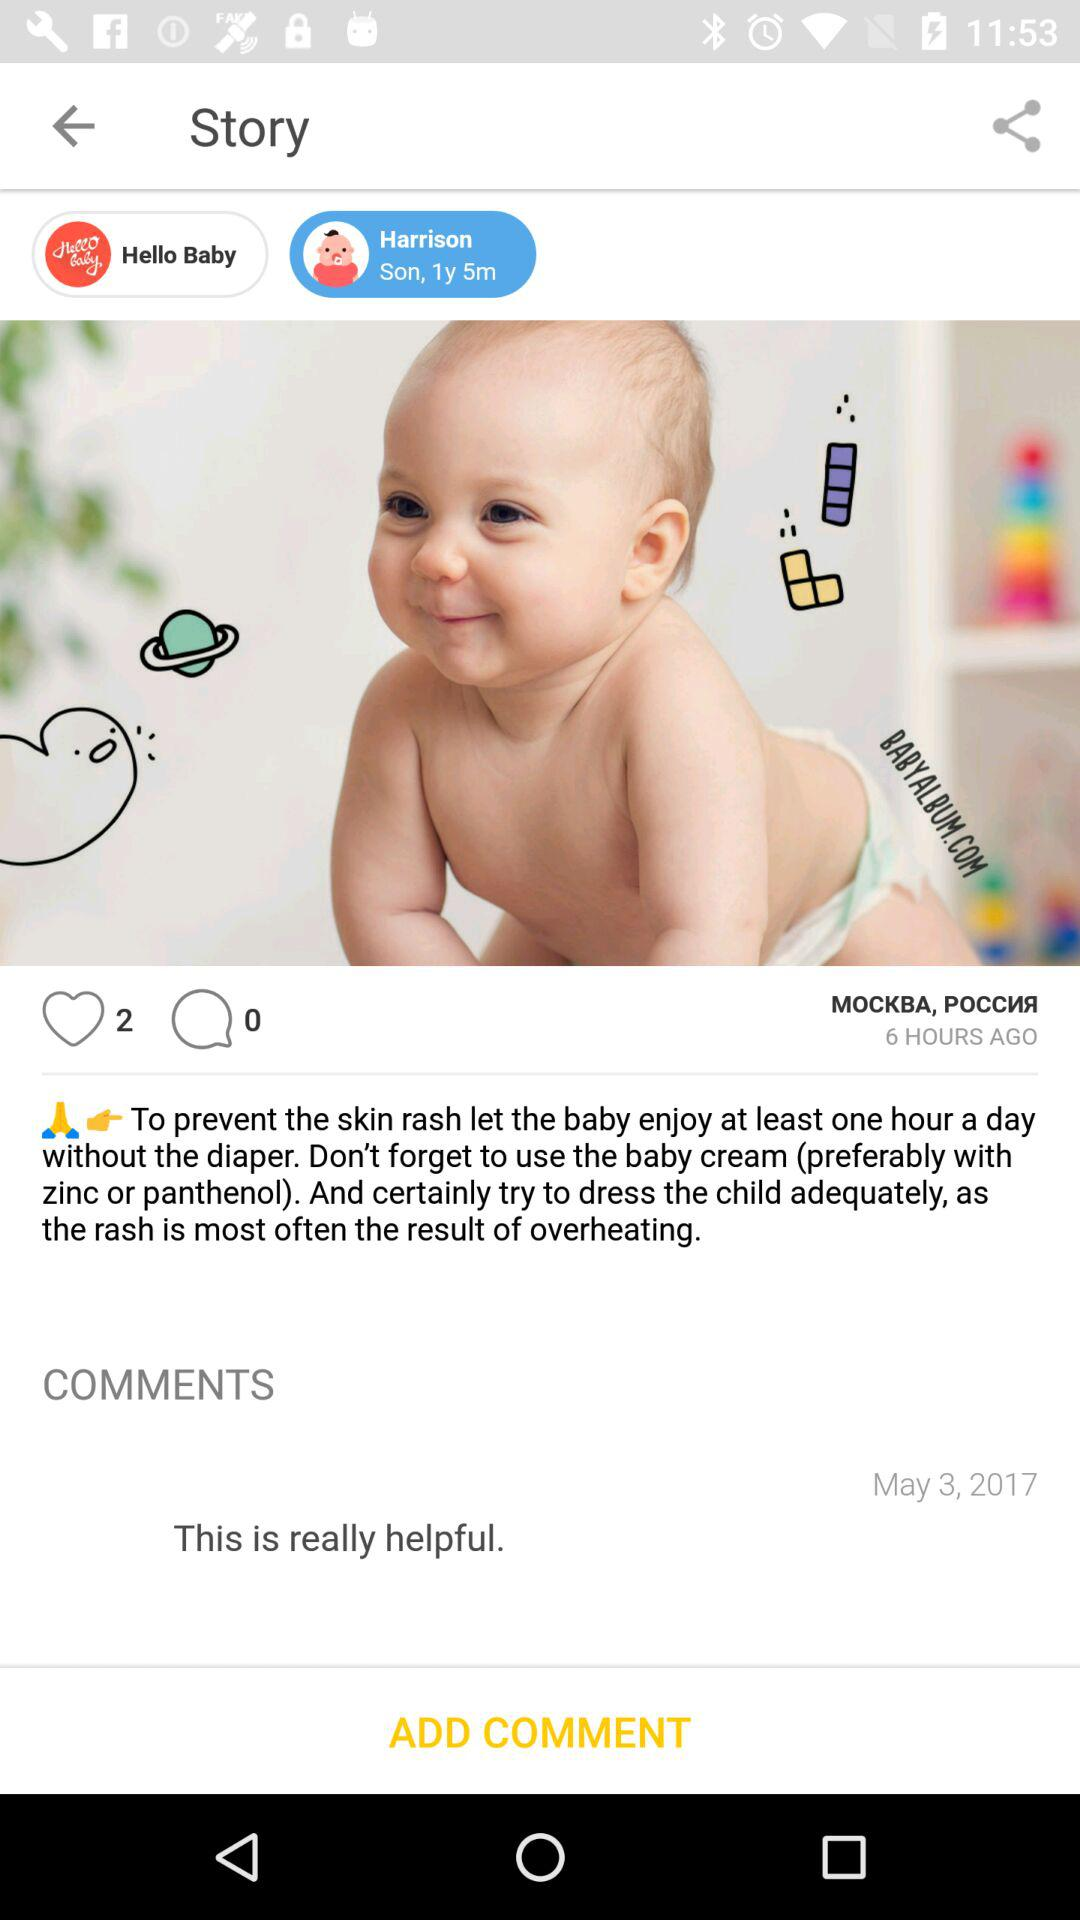Which date is reflected on the screen? The date reflected on the screen is May 3, 2017. 